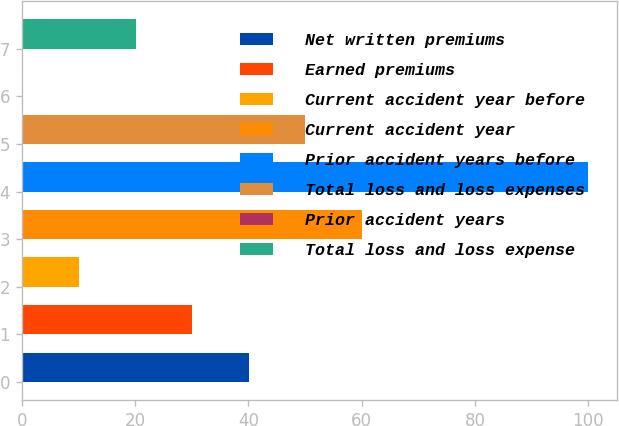<chart> <loc_0><loc_0><loc_500><loc_500><bar_chart><fcel>Net written premiums<fcel>Earned premiums<fcel>Current accident year before<fcel>Current accident year<fcel>Prior accident years before<fcel>Total loss and loss expenses<fcel>Prior accident years<fcel>Total loss and loss expense<nl><fcel>40.08<fcel>30.1<fcel>10.14<fcel>60.04<fcel>100<fcel>50.06<fcel>0.16<fcel>20.12<nl></chart> 